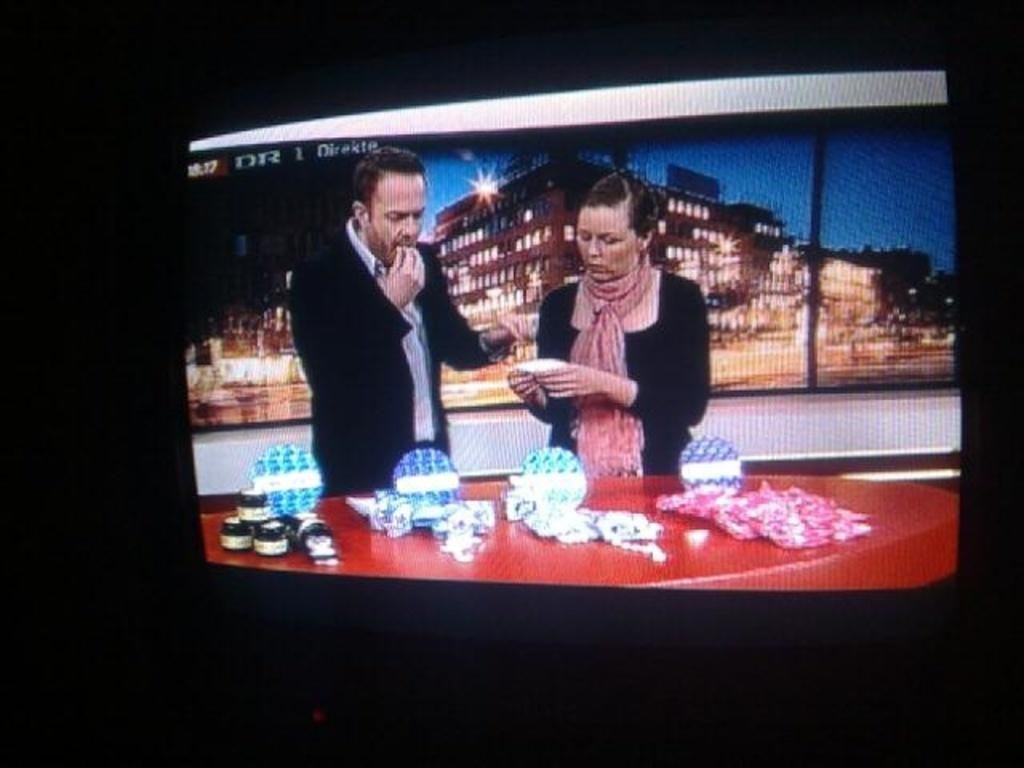Provide a one-sentence caption for the provided image. Two people on a talk show at taking place at 10:17 on DR. 